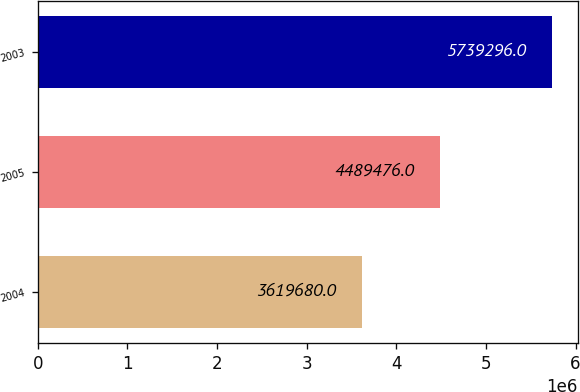Convert chart to OTSL. <chart><loc_0><loc_0><loc_500><loc_500><bar_chart><fcel>2004<fcel>2005<fcel>2003<nl><fcel>3.61968e+06<fcel>4.48948e+06<fcel>5.7393e+06<nl></chart> 